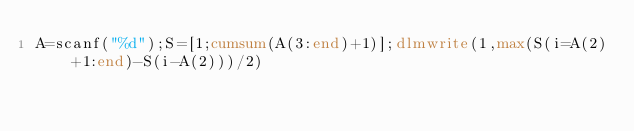Convert code to text. <code><loc_0><loc_0><loc_500><loc_500><_Octave_>A=scanf("%d");S=[1;cumsum(A(3:end)+1)];dlmwrite(1,max(S(i=A(2)+1:end)-S(i-A(2)))/2)</code> 